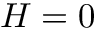<formula> <loc_0><loc_0><loc_500><loc_500>H = 0</formula> 